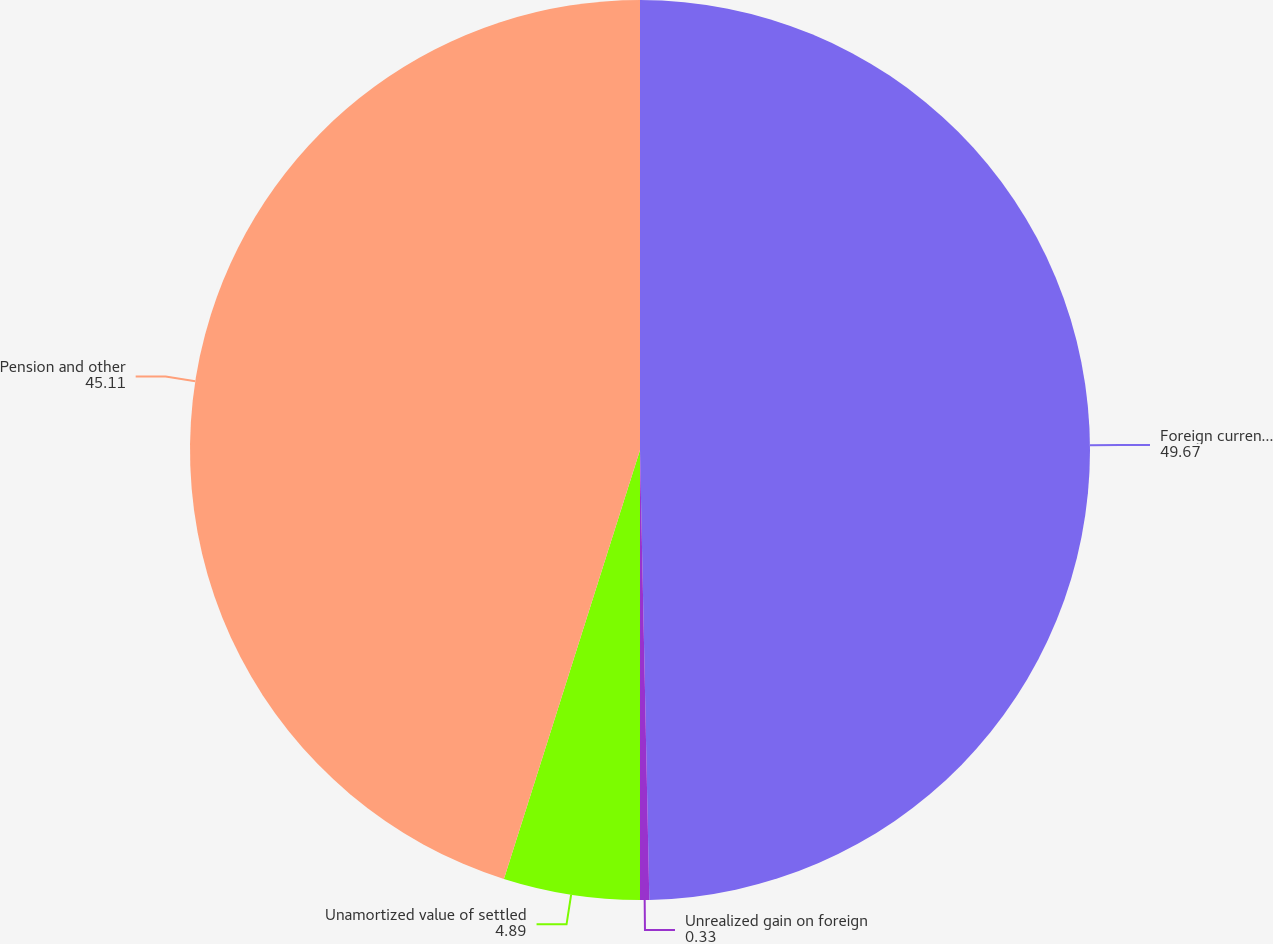Convert chart. <chart><loc_0><loc_0><loc_500><loc_500><pie_chart><fcel>Foreign currency translation<fcel>Unrealized gain on foreign<fcel>Unamortized value of settled<fcel>Pension and other<nl><fcel>49.67%<fcel>0.33%<fcel>4.89%<fcel>45.11%<nl></chart> 